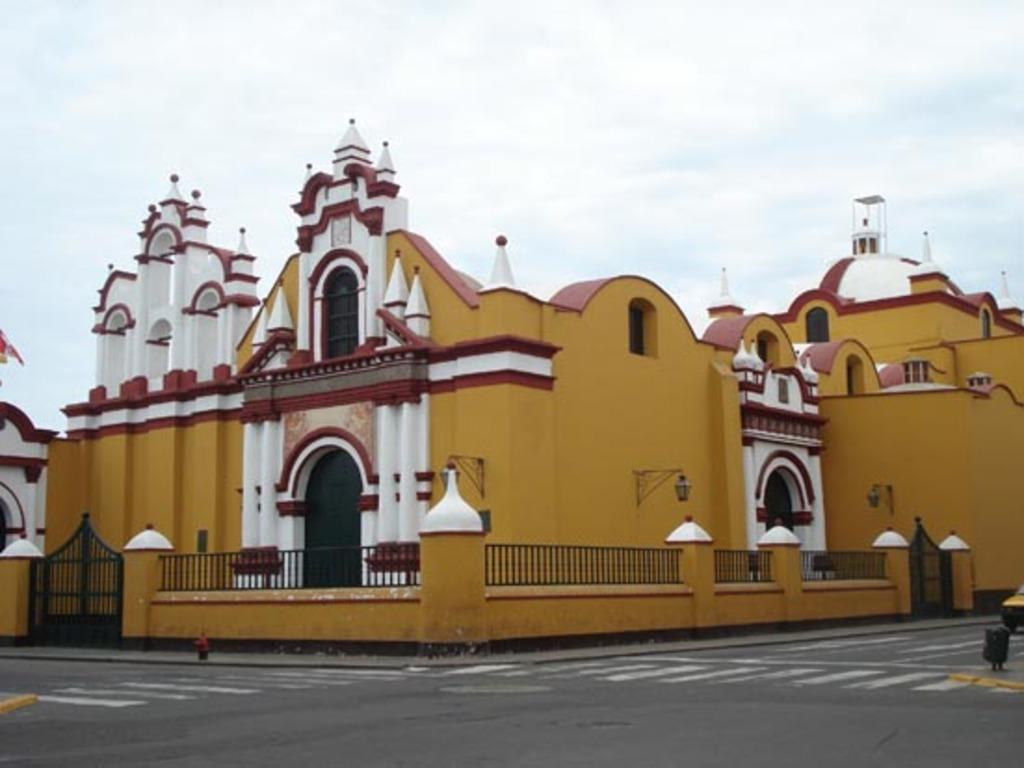What is located at the front of the image? There is a road in the front of the image. What can be seen behind the road? There are buildings behind the road. What type of buildings are depicted in the image? The buildings resemble a castle. What is visible in the background of the image? The sky is visible in the image. What can be observed in the sky? Clouds are present in the sky. What type of curtain is hanging in the castle in the image? There is no curtain present in the image; it features a road, buildings resembling a castle, and a sky with clouds. What is the plot of the story unfolding in the image? There is no story or plot depicted in the image; it is a static representation of a road, buildings, and the sky. 